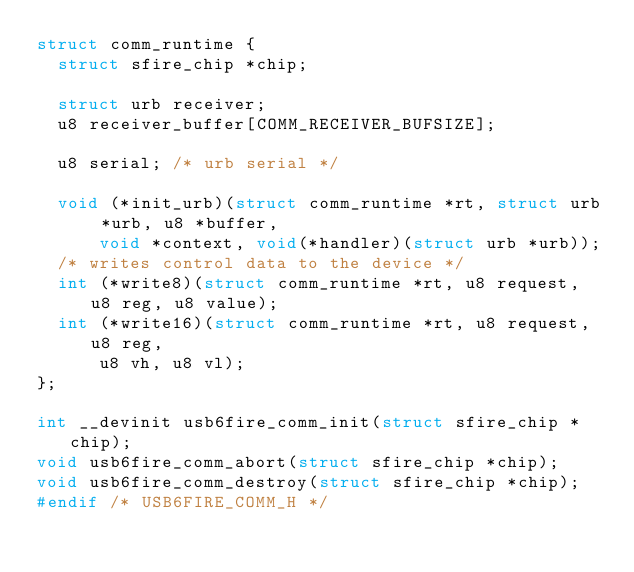<code> <loc_0><loc_0><loc_500><loc_500><_C_>struct comm_runtime {
	struct sfire_chip *chip;

	struct urb receiver;
	u8 receiver_buffer[COMM_RECEIVER_BUFSIZE];

	u8 serial; /* urb serial */

	void (*init_urb)(struct comm_runtime *rt, struct urb *urb, u8 *buffer,
			void *context, void(*handler)(struct urb *urb));
	/* writes control data to the device */
	int (*write8)(struct comm_runtime *rt, u8 request, u8 reg, u8 value);
	int (*write16)(struct comm_runtime *rt, u8 request, u8 reg,
			u8 vh, u8 vl);
};

int __devinit usb6fire_comm_init(struct sfire_chip *chip);
void usb6fire_comm_abort(struct sfire_chip *chip);
void usb6fire_comm_destroy(struct sfire_chip *chip);
#endif /* USB6FIRE_COMM_H */
</code> 